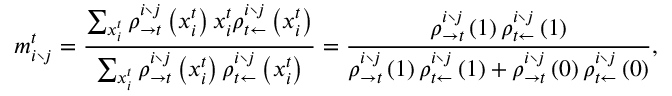<formula> <loc_0><loc_0><loc_500><loc_500>m _ { i \ j } ^ { t } = \frac { \sum _ { x _ { i } ^ { t } } \rho _ { \rightarrow t } ^ { i \ j } \left ( x _ { i } ^ { t } \right ) x _ { i } ^ { t } \rho _ { t \leftarrow } ^ { i \ j } \left ( x _ { i } ^ { t } \right ) } { \sum _ { x _ { i } ^ { t } } \rho _ { \rightarrow t } ^ { i \ j } \left ( x _ { i } ^ { t } \right ) \rho _ { t \leftarrow } ^ { i \ j } \left ( x _ { i } ^ { t } \right ) } = \frac { \rho _ { \rightarrow t } ^ { i \ j } \left ( 1 \right ) \rho _ { t \leftarrow } ^ { i \ j } \left ( 1 \right ) } { \rho _ { \rightarrow t } ^ { i \ j } \left ( 1 \right ) \rho _ { t \leftarrow } ^ { i \ j } \left ( 1 \right ) + \rho _ { \rightarrow t } ^ { i \ j } \left ( 0 \right ) \rho _ { t \leftarrow } ^ { i \ j } \left ( 0 \right ) } ,</formula> 